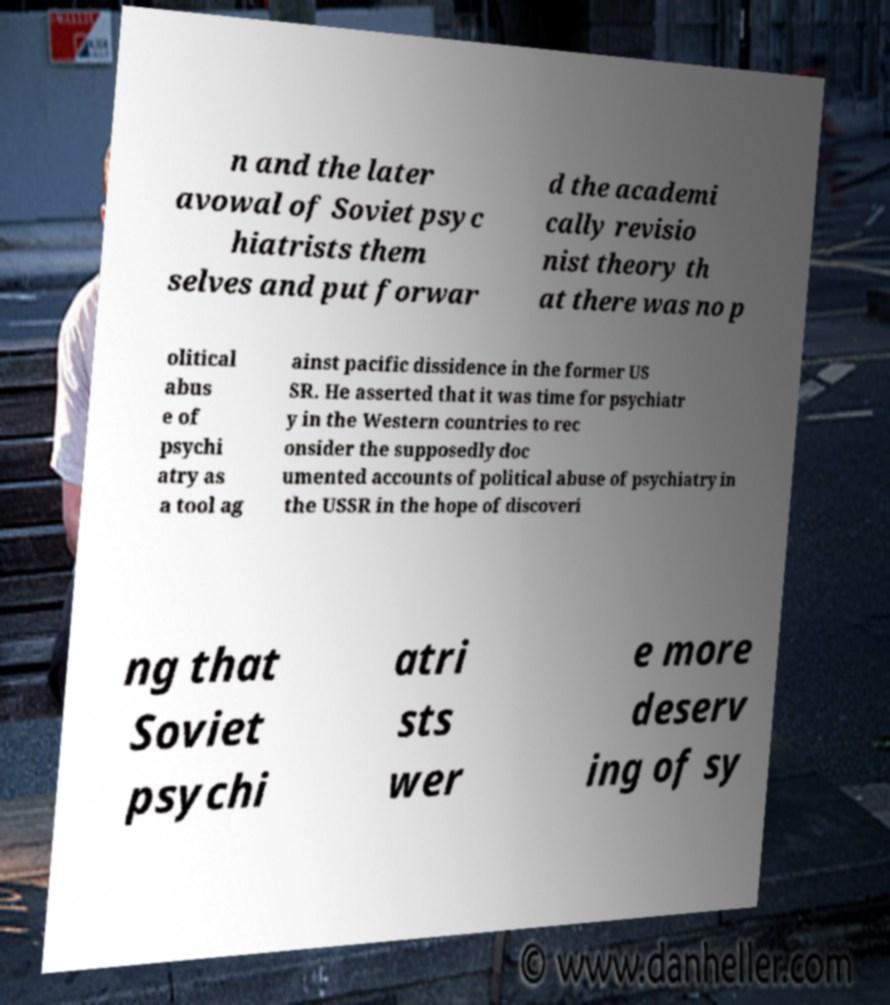Please read and relay the text visible in this image. What does it say? n and the later avowal of Soviet psyc hiatrists them selves and put forwar d the academi cally revisio nist theory th at there was no p olitical abus e of psychi atry as a tool ag ainst pacific dissidence in the former US SR. He asserted that it was time for psychiatr y in the Western countries to rec onsider the supposedly doc umented accounts of political abuse of psychiatry in the USSR in the hope of discoveri ng that Soviet psychi atri sts wer e more deserv ing of sy 